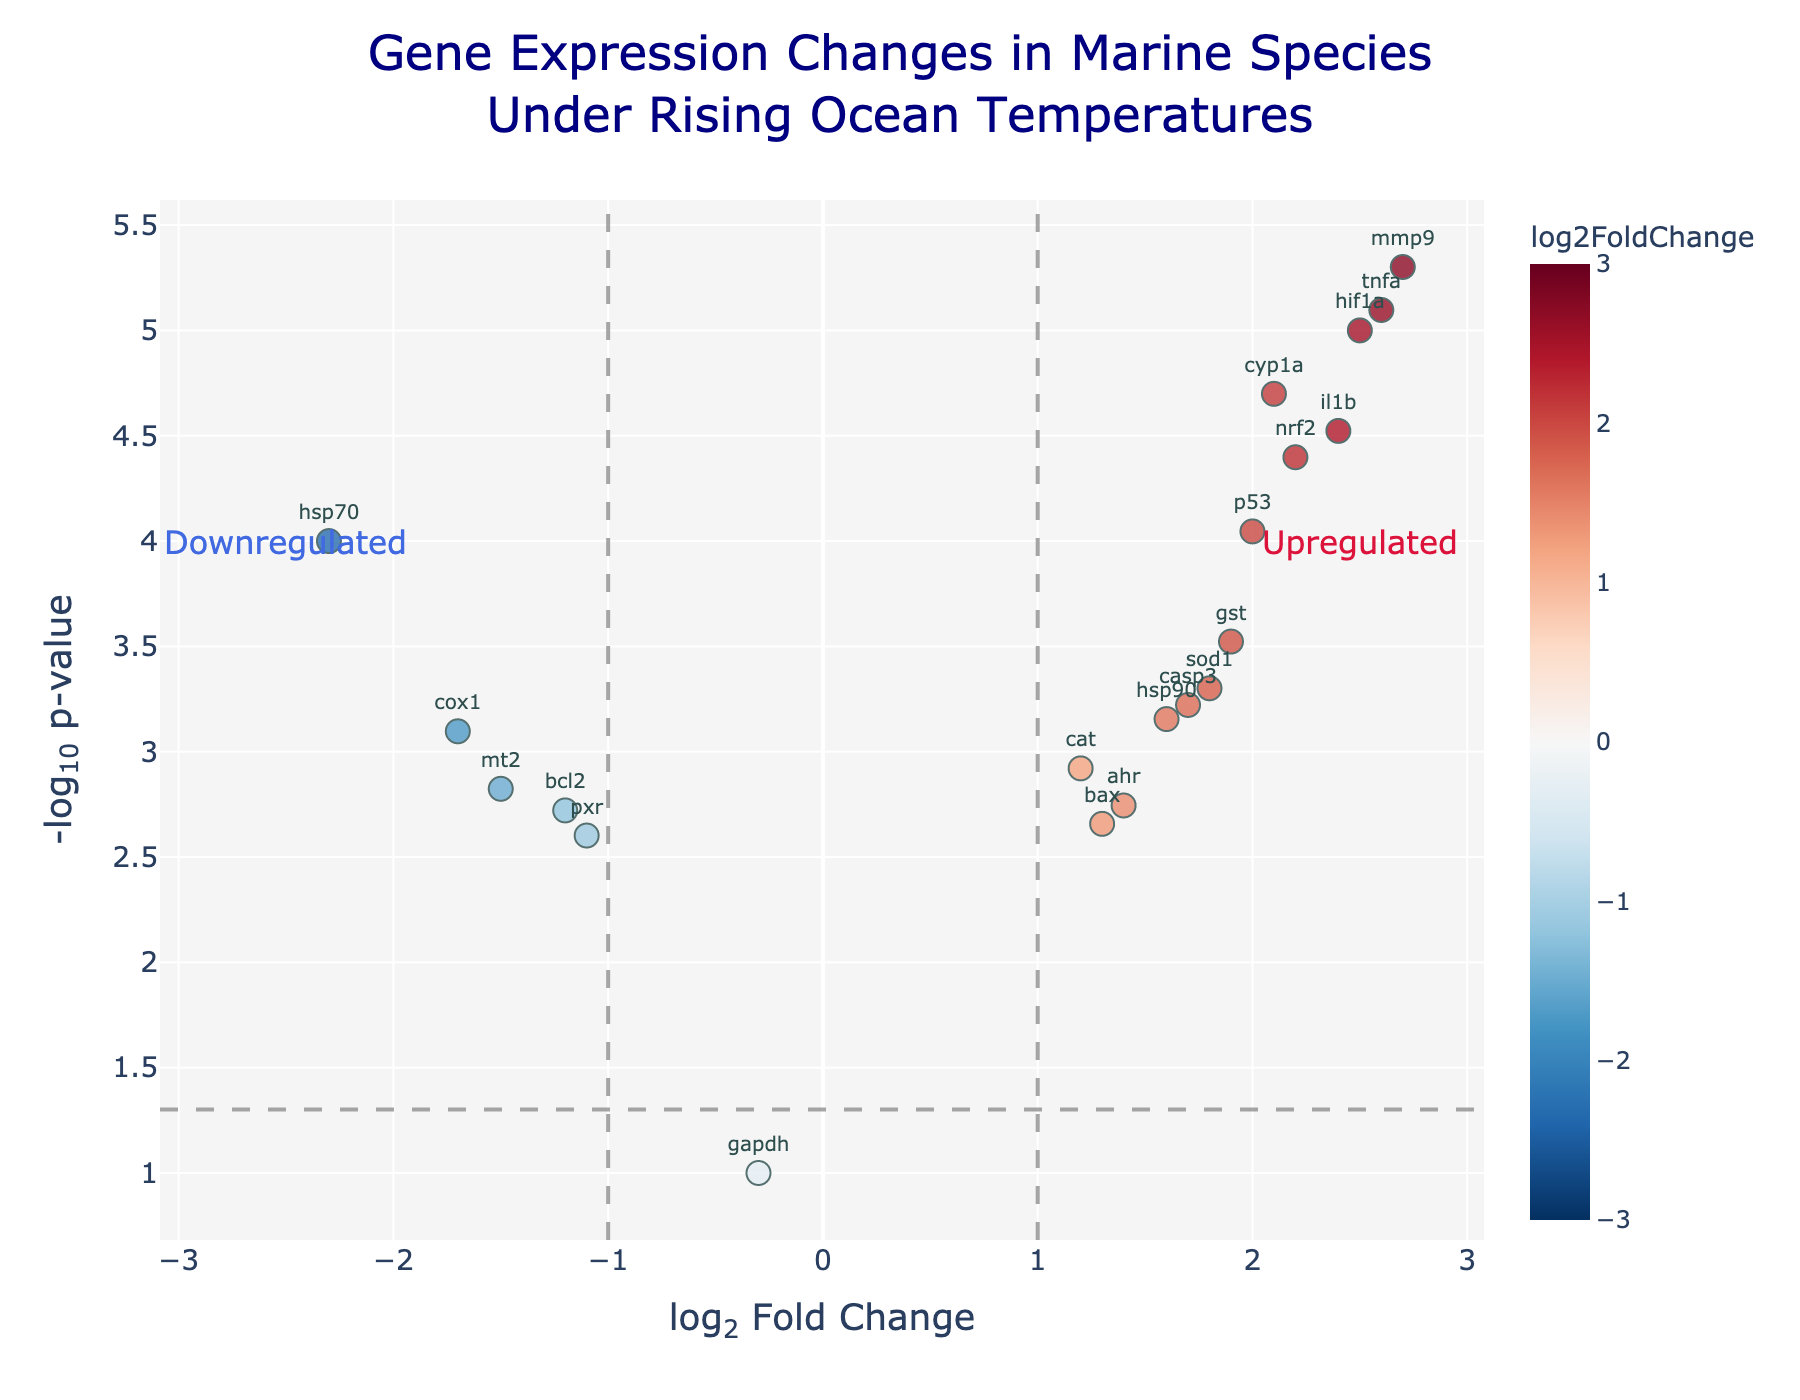How many genes are shown in the plot? Count the number of data points representing genes in the plot. Each point corresponds to one gene.
Answer: 20 Which gene is the most significantly upregulated? Look for the gene with the highest -log10(pvalue) on the positive side of the log2FoldChange axis. Check the hover text or text annotation for confirmation.
Answer: mmp9 What is the log2FoldChange of gene 'hsp70'? Find the point labeled 'hsp70' and note its position on the log2FoldChange axis.
Answer: -2.3 How many genes are significantly downregulated (log2FoldChange < -1, pvalue < 0.05)? Count the number of data points on the left of -1 on the log2FoldChange axis and above -log10(0.05) on the y-axis.
Answer: 4 Which gene is closest to the log2FoldChange threshold of 1 but not exceeding it? Identify the data point closest to the vertical line at log2FoldChange = 1 without crossing to the right. Check annotations or hover text for confirmation.
Answer: cat Is gene 'p53' upregulated or downregulated? Find the point labeled 'p53' and check whether it is on the positive or negative side of the log2FoldChange axis.
Answer: Upregulated Among genes 'sod1' and 'cox1', which has a lower p-value? Compare the -log10(pvalue) values of 'sod1' and 'cox1' and determine which one is higher on the -log10(pvalue) axis.
Answer: sod1 What is the -log10(pvalue) of the most significantly upregulated gene? Find the highest y-value on the plot for a positively positioned log2FoldChange and read the -log10(pvalue) value from the y-axis.
Answer: 5.3 For the most downregulated gene, what is the difference between the absolute values of its log2FoldChange and -log10(pvalue)? Identify the most downregulated gene, find its log2FoldChange and -log10(pvalue), take absolute values if necessary, and compute the difference.
Answer: Difference: 3.2 (gene: hsp70, log2FoldChange: 2.3, -log10(pvalue): 4) Which area of the plot represents genes that are both highly upregulated and highly significant? Identify the region with positive log2FoldChange values greater than 1 and high -log10(pvalue) values above 1.3.
Answer: Top right quadrant 